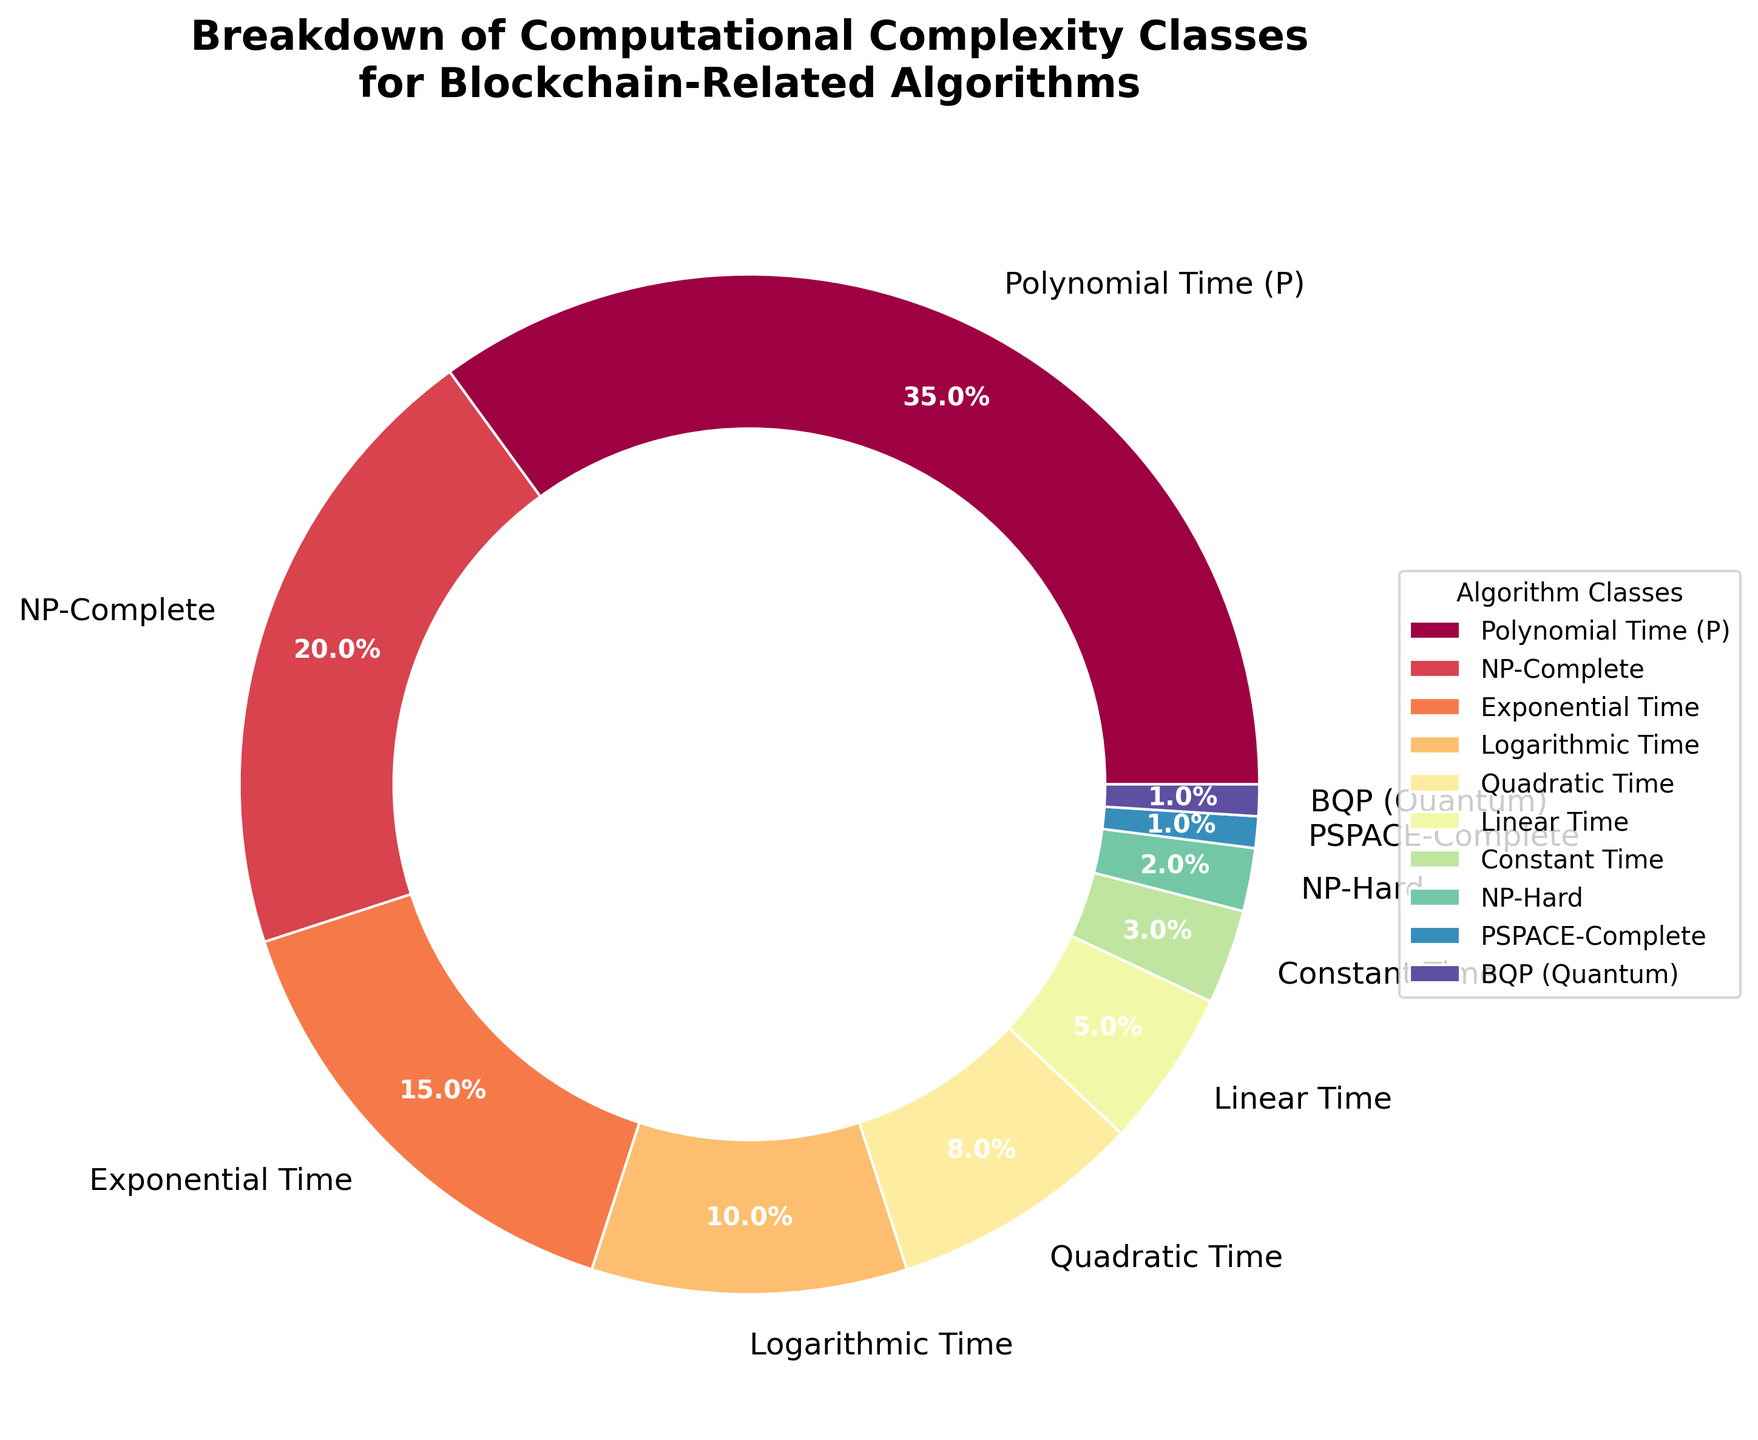What percentage of the algorithms fall into complexity classes that take at most quadratic time? To find this, we sum the percentages for the classes that are at most quadratic time: Polynomial Time (P) is 35%, Logarithmic Time is 10%, Quadratic Time is 8%, Linear Time is 5%, and Constant Time is 3%. So, 35% + 10% + 8% + 5% + 3% = 61%.
Answer: 61% Which complexity class has the smallest percentage, and what is it? We look for the smallest percentage in the figure. PSPACE-Complete and BQP (Quantum) both account for the smallest percentage, 1%.
Answer: PSPACE-Complete and BQP (Quantum) Are there more NP-Hard algorithms or exponential time algorithms? We compare the percentage of NP-Hard algorithms (2%) to the exponential time algorithms (15%). Since 15% is greater than 2%, there are more exponential time algorithms.
Answer: Exponential Time What's the total percentage of NP-Complexity classes (NP-Complete and NP-Hard combined)? The percentage of NP-Complete algorithms is 20%, and NP-Hard algorithms is 2%. Summing them up gives 20% + 2% = 22%.
Answer: 22% What percentage of the algorithms are categorized under Polynomial Time (P) compared to those under NP-Complete? Polynomial Time (P) algorithms account for 35%, whereas NP-Complete algorithms account for 20%. We compare 35% to 20%.
Answer: Polynomial Time (P) is greater If the pie chart were divided into two segments separating Polynomial Time (P), NP-Complete, and the rest, what would be the respective percentages? Polynomial Time (P) is 35% and NP-Complete is 20%, summing these gives 35% + 20% = 55%. The rest of the percentages add up to 100% - 55% = 45%. So, one segment is 55% and the other is 45%.
Answer: 55% and 45% Considering only Polynomial Time (P) and Logarithmic Time classes, what is the difference in their percentages? Polynomial Time (P) is 35% while Logarithmic Time is 10%. The difference is 35% - 10% = 25%.
Answer: 25% Which classes collectively make up a quarter of the total percentage? We need to find classes whose percentages sum up to 25%. The smallest classes that add up to this are NP-Hard (2%), PSPACE-Complete (1%), BQP (Quantum) (1%), Constant Time (3%), Linear Time (5%), and Quadratic Time (8%). These total to 2% + 1% + 1% + 3% + 5% + 8% = 20%. Adding Exponential Time (15%) would exceed, so NP-Complete (20%) is the suitable class. Thus, NP-Hard + PSPACE-Complete + BQP (Quantum) + Constant Time + Linear Time + Quadratic Time closely approach half and overachieve by counting the next large category. We exclude any combination that totals 25%.
Answer: Multiple classes Which group has a higher percentage, Quadratic Time or Exponential Time? Quadratic Time is depicted as 8% and Exponential Time is 15%. Comparing these, Exponential Time has a higher percentage.
Answer: Exponential Time 